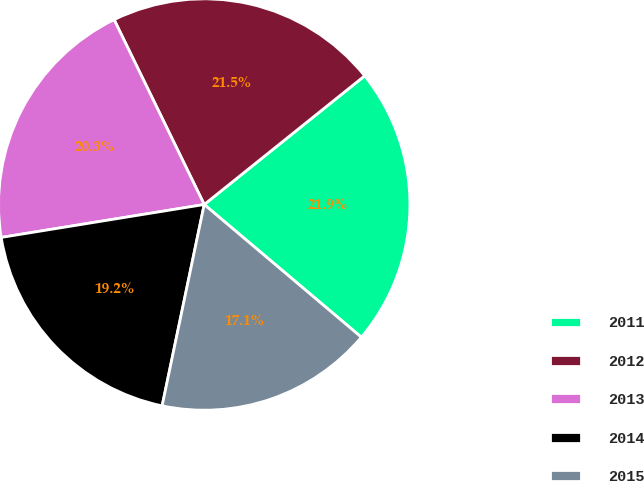<chart> <loc_0><loc_0><loc_500><loc_500><pie_chart><fcel>2011<fcel>2012<fcel>2013<fcel>2014<fcel>2015<nl><fcel>21.92%<fcel>21.46%<fcel>20.34%<fcel>19.16%<fcel>17.12%<nl></chart> 